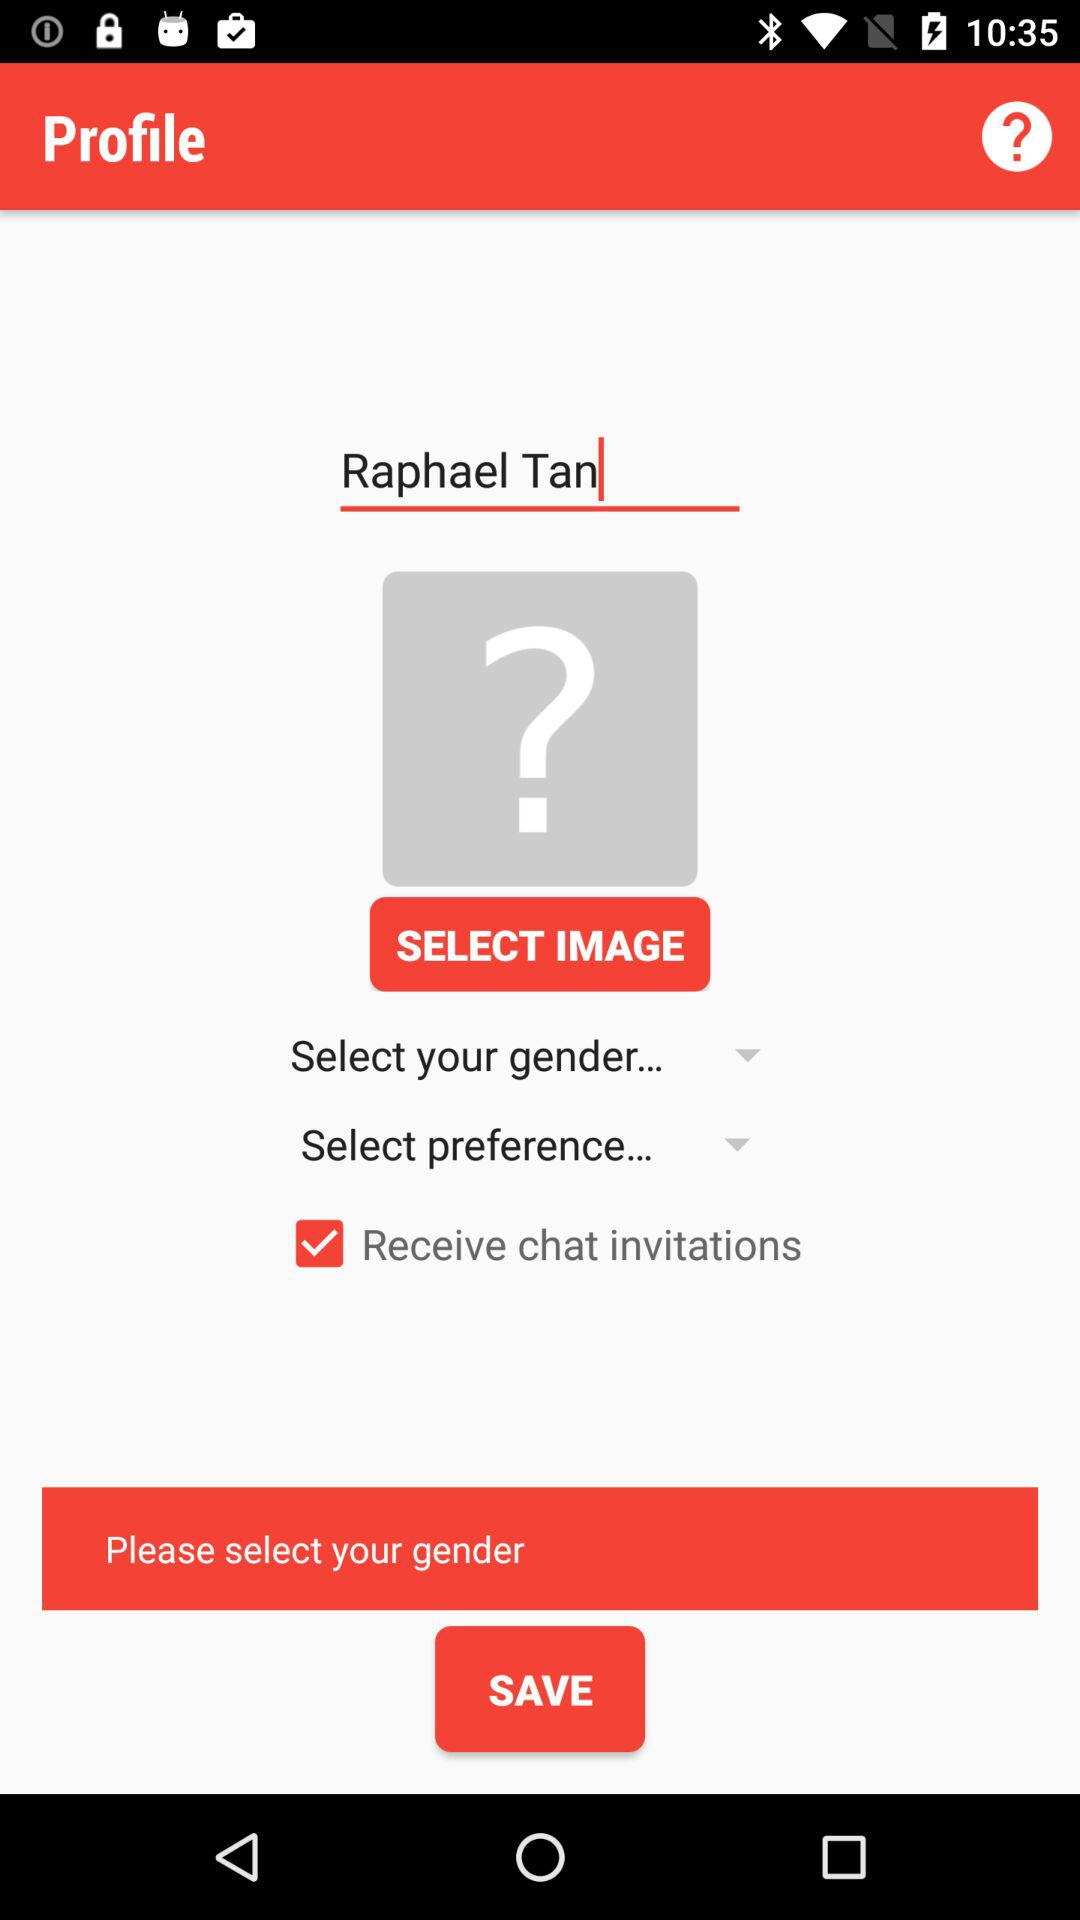What is the status of "Receive chat invitations"? The status is "on". 